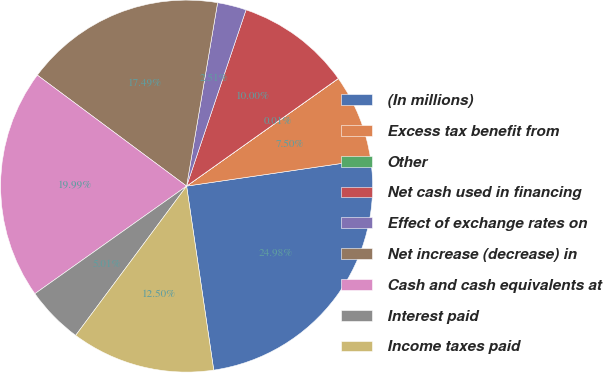Convert chart to OTSL. <chart><loc_0><loc_0><loc_500><loc_500><pie_chart><fcel>(In millions)<fcel>Excess tax benefit from<fcel>Other<fcel>Net cash used in financing<fcel>Effect of exchange rates on<fcel>Net increase (decrease) in<fcel>Cash and cash equivalents at<fcel>Interest paid<fcel>Income taxes paid<nl><fcel>24.98%<fcel>7.5%<fcel>0.01%<fcel>10.0%<fcel>2.51%<fcel>17.49%<fcel>19.99%<fcel>5.01%<fcel>12.5%<nl></chart> 